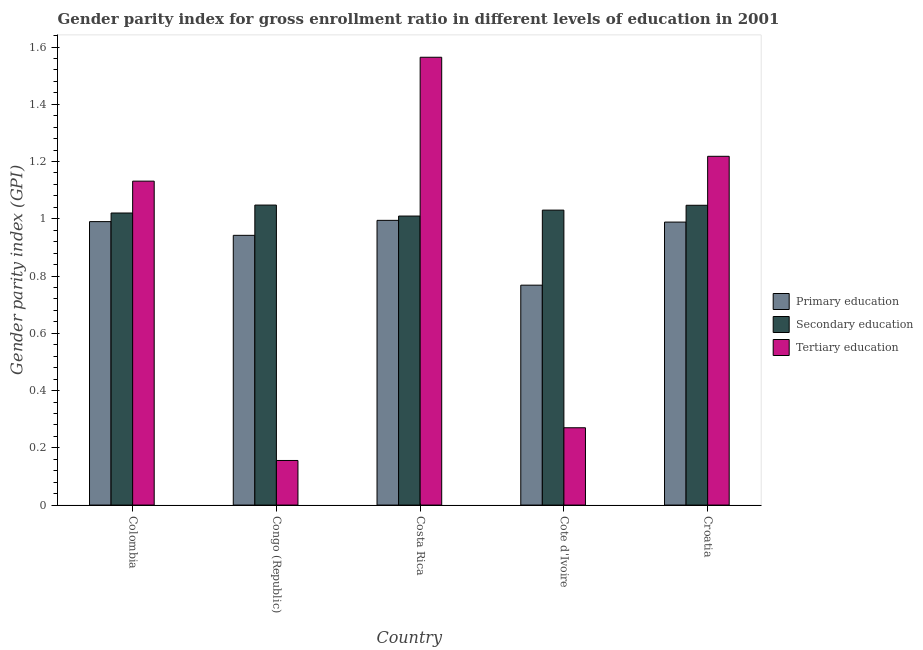How many different coloured bars are there?
Keep it short and to the point. 3. How many groups of bars are there?
Your answer should be very brief. 5. Are the number of bars on each tick of the X-axis equal?
Keep it short and to the point. Yes. How many bars are there on the 1st tick from the left?
Offer a terse response. 3. How many bars are there on the 4th tick from the right?
Offer a terse response. 3. What is the label of the 4th group of bars from the left?
Make the answer very short. Cote d'Ivoire. In how many cases, is the number of bars for a given country not equal to the number of legend labels?
Provide a short and direct response. 0. What is the gender parity index in secondary education in Costa Rica?
Your answer should be compact. 1.01. Across all countries, what is the maximum gender parity index in tertiary education?
Provide a short and direct response. 1.56. Across all countries, what is the minimum gender parity index in tertiary education?
Provide a short and direct response. 0.16. In which country was the gender parity index in primary education maximum?
Your answer should be compact. Costa Rica. In which country was the gender parity index in tertiary education minimum?
Provide a short and direct response. Congo (Republic). What is the total gender parity index in secondary education in the graph?
Give a very brief answer. 5.16. What is the difference between the gender parity index in primary education in Colombia and that in Croatia?
Provide a succinct answer. 0. What is the difference between the gender parity index in secondary education in Congo (Republic) and the gender parity index in tertiary education in Colombia?
Keep it short and to the point. -0.08. What is the average gender parity index in secondary education per country?
Your answer should be very brief. 1.03. What is the difference between the gender parity index in tertiary education and gender parity index in secondary education in Croatia?
Offer a terse response. 0.17. In how many countries, is the gender parity index in primary education greater than 0.8400000000000001 ?
Make the answer very short. 4. What is the ratio of the gender parity index in tertiary education in Costa Rica to that in Croatia?
Your answer should be compact. 1.28. What is the difference between the highest and the second highest gender parity index in tertiary education?
Make the answer very short. 0.35. What is the difference between the highest and the lowest gender parity index in tertiary education?
Make the answer very short. 1.41. In how many countries, is the gender parity index in primary education greater than the average gender parity index in primary education taken over all countries?
Your answer should be very brief. 4. What does the 3rd bar from the left in Croatia represents?
Keep it short and to the point. Tertiary education. What does the 2nd bar from the right in Cote d'Ivoire represents?
Your response must be concise. Secondary education. How many countries are there in the graph?
Give a very brief answer. 5. What is the difference between two consecutive major ticks on the Y-axis?
Offer a very short reply. 0.2. Does the graph contain any zero values?
Your response must be concise. No. Where does the legend appear in the graph?
Your answer should be compact. Center right. How many legend labels are there?
Your response must be concise. 3. How are the legend labels stacked?
Your answer should be very brief. Vertical. What is the title of the graph?
Ensure brevity in your answer.  Gender parity index for gross enrollment ratio in different levels of education in 2001. What is the label or title of the X-axis?
Your answer should be very brief. Country. What is the label or title of the Y-axis?
Offer a very short reply. Gender parity index (GPI). What is the Gender parity index (GPI) in Primary education in Colombia?
Give a very brief answer. 0.99. What is the Gender parity index (GPI) of Secondary education in Colombia?
Provide a succinct answer. 1.02. What is the Gender parity index (GPI) in Tertiary education in Colombia?
Offer a very short reply. 1.13. What is the Gender parity index (GPI) of Primary education in Congo (Republic)?
Make the answer very short. 0.94. What is the Gender parity index (GPI) of Secondary education in Congo (Republic)?
Keep it short and to the point. 1.05. What is the Gender parity index (GPI) in Tertiary education in Congo (Republic)?
Your response must be concise. 0.16. What is the Gender parity index (GPI) of Primary education in Costa Rica?
Offer a very short reply. 0.99. What is the Gender parity index (GPI) of Secondary education in Costa Rica?
Offer a very short reply. 1.01. What is the Gender parity index (GPI) in Tertiary education in Costa Rica?
Make the answer very short. 1.56. What is the Gender parity index (GPI) in Primary education in Cote d'Ivoire?
Your answer should be very brief. 0.77. What is the Gender parity index (GPI) of Secondary education in Cote d'Ivoire?
Your answer should be compact. 1.03. What is the Gender parity index (GPI) of Tertiary education in Cote d'Ivoire?
Your response must be concise. 0.27. What is the Gender parity index (GPI) of Primary education in Croatia?
Ensure brevity in your answer.  0.99. What is the Gender parity index (GPI) in Secondary education in Croatia?
Provide a succinct answer. 1.05. What is the Gender parity index (GPI) in Tertiary education in Croatia?
Provide a short and direct response. 1.22. Across all countries, what is the maximum Gender parity index (GPI) in Primary education?
Offer a terse response. 0.99. Across all countries, what is the maximum Gender parity index (GPI) of Secondary education?
Keep it short and to the point. 1.05. Across all countries, what is the maximum Gender parity index (GPI) of Tertiary education?
Keep it short and to the point. 1.56. Across all countries, what is the minimum Gender parity index (GPI) of Primary education?
Give a very brief answer. 0.77. Across all countries, what is the minimum Gender parity index (GPI) in Secondary education?
Provide a succinct answer. 1.01. Across all countries, what is the minimum Gender parity index (GPI) of Tertiary education?
Offer a very short reply. 0.16. What is the total Gender parity index (GPI) in Primary education in the graph?
Keep it short and to the point. 4.68. What is the total Gender parity index (GPI) of Secondary education in the graph?
Provide a succinct answer. 5.16. What is the total Gender parity index (GPI) in Tertiary education in the graph?
Ensure brevity in your answer.  4.34. What is the difference between the Gender parity index (GPI) in Primary education in Colombia and that in Congo (Republic)?
Ensure brevity in your answer.  0.05. What is the difference between the Gender parity index (GPI) in Secondary education in Colombia and that in Congo (Republic)?
Provide a succinct answer. -0.03. What is the difference between the Gender parity index (GPI) of Tertiary education in Colombia and that in Congo (Republic)?
Provide a succinct answer. 0.98. What is the difference between the Gender parity index (GPI) in Primary education in Colombia and that in Costa Rica?
Ensure brevity in your answer.  -0. What is the difference between the Gender parity index (GPI) in Secondary education in Colombia and that in Costa Rica?
Your response must be concise. 0.01. What is the difference between the Gender parity index (GPI) in Tertiary education in Colombia and that in Costa Rica?
Your answer should be very brief. -0.43. What is the difference between the Gender parity index (GPI) in Primary education in Colombia and that in Cote d'Ivoire?
Keep it short and to the point. 0.22. What is the difference between the Gender parity index (GPI) in Secondary education in Colombia and that in Cote d'Ivoire?
Your answer should be very brief. -0.01. What is the difference between the Gender parity index (GPI) of Tertiary education in Colombia and that in Cote d'Ivoire?
Offer a terse response. 0.86. What is the difference between the Gender parity index (GPI) in Primary education in Colombia and that in Croatia?
Your answer should be compact. 0. What is the difference between the Gender parity index (GPI) in Secondary education in Colombia and that in Croatia?
Keep it short and to the point. -0.03. What is the difference between the Gender parity index (GPI) of Tertiary education in Colombia and that in Croatia?
Keep it short and to the point. -0.09. What is the difference between the Gender parity index (GPI) in Primary education in Congo (Republic) and that in Costa Rica?
Offer a very short reply. -0.05. What is the difference between the Gender parity index (GPI) of Secondary education in Congo (Republic) and that in Costa Rica?
Provide a short and direct response. 0.04. What is the difference between the Gender parity index (GPI) in Tertiary education in Congo (Republic) and that in Costa Rica?
Your response must be concise. -1.41. What is the difference between the Gender parity index (GPI) of Primary education in Congo (Republic) and that in Cote d'Ivoire?
Keep it short and to the point. 0.17. What is the difference between the Gender parity index (GPI) of Secondary education in Congo (Republic) and that in Cote d'Ivoire?
Ensure brevity in your answer.  0.02. What is the difference between the Gender parity index (GPI) of Tertiary education in Congo (Republic) and that in Cote d'Ivoire?
Give a very brief answer. -0.11. What is the difference between the Gender parity index (GPI) of Primary education in Congo (Republic) and that in Croatia?
Keep it short and to the point. -0.05. What is the difference between the Gender parity index (GPI) of Secondary education in Congo (Republic) and that in Croatia?
Offer a very short reply. 0. What is the difference between the Gender parity index (GPI) of Tertiary education in Congo (Republic) and that in Croatia?
Provide a succinct answer. -1.06. What is the difference between the Gender parity index (GPI) of Primary education in Costa Rica and that in Cote d'Ivoire?
Your answer should be compact. 0.23. What is the difference between the Gender parity index (GPI) in Secondary education in Costa Rica and that in Cote d'Ivoire?
Provide a short and direct response. -0.02. What is the difference between the Gender parity index (GPI) in Tertiary education in Costa Rica and that in Cote d'Ivoire?
Provide a short and direct response. 1.29. What is the difference between the Gender parity index (GPI) of Primary education in Costa Rica and that in Croatia?
Your response must be concise. 0.01. What is the difference between the Gender parity index (GPI) of Secondary education in Costa Rica and that in Croatia?
Offer a very short reply. -0.04. What is the difference between the Gender parity index (GPI) of Tertiary education in Costa Rica and that in Croatia?
Provide a short and direct response. 0.35. What is the difference between the Gender parity index (GPI) in Primary education in Cote d'Ivoire and that in Croatia?
Ensure brevity in your answer.  -0.22. What is the difference between the Gender parity index (GPI) in Secondary education in Cote d'Ivoire and that in Croatia?
Offer a very short reply. -0.02. What is the difference between the Gender parity index (GPI) of Tertiary education in Cote d'Ivoire and that in Croatia?
Give a very brief answer. -0.95. What is the difference between the Gender parity index (GPI) in Primary education in Colombia and the Gender parity index (GPI) in Secondary education in Congo (Republic)?
Your answer should be very brief. -0.06. What is the difference between the Gender parity index (GPI) in Primary education in Colombia and the Gender parity index (GPI) in Tertiary education in Congo (Republic)?
Keep it short and to the point. 0.83. What is the difference between the Gender parity index (GPI) in Secondary education in Colombia and the Gender parity index (GPI) in Tertiary education in Congo (Republic)?
Offer a very short reply. 0.86. What is the difference between the Gender parity index (GPI) of Primary education in Colombia and the Gender parity index (GPI) of Secondary education in Costa Rica?
Your response must be concise. -0.02. What is the difference between the Gender parity index (GPI) in Primary education in Colombia and the Gender parity index (GPI) in Tertiary education in Costa Rica?
Make the answer very short. -0.57. What is the difference between the Gender parity index (GPI) in Secondary education in Colombia and the Gender parity index (GPI) in Tertiary education in Costa Rica?
Your response must be concise. -0.54. What is the difference between the Gender parity index (GPI) of Primary education in Colombia and the Gender parity index (GPI) of Secondary education in Cote d'Ivoire?
Your answer should be very brief. -0.04. What is the difference between the Gender parity index (GPI) in Primary education in Colombia and the Gender parity index (GPI) in Tertiary education in Cote d'Ivoire?
Ensure brevity in your answer.  0.72. What is the difference between the Gender parity index (GPI) in Secondary education in Colombia and the Gender parity index (GPI) in Tertiary education in Cote d'Ivoire?
Provide a short and direct response. 0.75. What is the difference between the Gender parity index (GPI) in Primary education in Colombia and the Gender parity index (GPI) in Secondary education in Croatia?
Keep it short and to the point. -0.06. What is the difference between the Gender parity index (GPI) of Primary education in Colombia and the Gender parity index (GPI) of Tertiary education in Croatia?
Provide a short and direct response. -0.23. What is the difference between the Gender parity index (GPI) of Secondary education in Colombia and the Gender parity index (GPI) of Tertiary education in Croatia?
Provide a succinct answer. -0.2. What is the difference between the Gender parity index (GPI) of Primary education in Congo (Republic) and the Gender parity index (GPI) of Secondary education in Costa Rica?
Your response must be concise. -0.07. What is the difference between the Gender parity index (GPI) in Primary education in Congo (Republic) and the Gender parity index (GPI) in Tertiary education in Costa Rica?
Your response must be concise. -0.62. What is the difference between the Gender parity index (GPI) of Secondary education in Congo (Republic) and the Gender parity index (GPI) of Tertiary education in Costa Rica?
Keep it short and to the point. -0.52. What is the difference between the Gender parity index (GPI) of Primary education in Congo (Republic) and the Gender parity index (GPI) of Secondary education in Cote d'Ivoire?
Offer a very short reply. -0.09. What is the difference between the Gender parity index (GPI) of Primary education in Congo (Republic) and the Gender parity index (GPI) of Tertiary education in Cote d'Ivoire?
Offer a terse response. 0.67. What is the difference between the Gender parity index (GPI) of Secondary education in Congo (Republic) and the Gender parity index (GPI) of Tertiary education in Cote d'Ivoire?
Keep it short and to the point. 0.78. What is the difference between the Gender parity index (GPI) in Primary education in Congo (Republic) and the Gender parity index (GPI) in Secondary education in Croatia?
Keep it short and to the point. -0.11. What is the difference between the Gender parity index (GPI) in Primary education in Congo (Republic) and the Gender parity index (GPI) in Tertiary education in Croatia?
Your answer should be compact. -0.28. What is the difference between the Gender parity index (GPI) of Secondary education in Congo (Republic) and the Gender parity index (GPI) of Tertiary education in Croatia?
Ensure brevity in your answer.  -0.17. What is the difference between the Gender parity index (GPI) of Primary education in Costa Rica and the Gender parity index (GPI) of Secondary education in Cote d'Ivoire?
Your answer should be very brief. -0.04. What is the difference between the Gender parity index (GPI) in Primary education in Costa Rica and the Gender parity index (GPI) in Tertiary education in Cote d'Ivoire?
Make the answer very short. 0.72. What is the difference between the Gender parity index (GPI) in Secondary education in Costa Rica and the Gender parity index (GPI) in Tertiary education in Cote d'Ivoire?
Your answer should be very brief. 0.74. What is the difference between the Gender parity index (GPI) of Primary education in Costa Rica and the Gender parity index (GPI) of Secondary education in Croatia?
Ensure brevity in your answer.  -0.05. What is the difference between the Gender parity index (GPI) of Primary education in Costa Rica and the Gender parity index (GPI) of Tertiary education in Croatia?
Your answer should be very brief. -0.22. What is the difference between the Gender parity index (GPI) of Secondary education in Costa Rica and the Gender parity index (GPI) of Tertiary education in Croatia?
Ensure brevity in your answer.  -0.21. What is the difference between the Gender parity index (GPI) in Primary education in Cote d'Ivoire and the Gender parity index (GPI) in Secondary education in Croatia?
Offer a terse response. -0.28. What is the difference between the Gender parity index (GPI) in Primary education in Cote d'Ivoire and the Gender parity index (GPI) in Tertiary education in Croatia?
Give a very brief answer. -0.45. What is the difference between the Gender parity index (GPI) in Secondary education in Cote d'Ivoire and the Gender parity index (GPI) in Tertiary education in Croatia?
Your answer should be very brief. -0.19. What is the average Gender parity index (GPI) in Primary education per country?
Keep it short and to the point. 0.94. What is the average Gender parity index (GPI) in Secondary education per country?
Offer a very short reply. 1.03. What is the average Gender parity index (GPI) in Tertiary education per country?
Your answer should be compact. 0.87. What is the difference between the Gender parity index (GPI) in Primary education and Gender parity index (GPI) in Secondary education in Colombia?
Provide a succinct answer. -0.03. What is the difference between the Gender parity index (GPI) of Primary education and Gender parity index (GPI) of Tertiary education in Colombia?
Provide a short and direct response. -0.14. What is the difference between the Gender parity index (GPI) in Secondary education and Gender parity index (GPI) in Tertiary education in Colombia?
Make the answer very short. -0.11. What is the difference between the Gender parity index (GPI) of Primary education and Gender parity index (GPI) of Secondary education in Congo (Republic)?
Make the answer very short. -0.11. What is the difference between the Gender parity index (GPI) of Primary education and Gender parity index (GPI) of Tertiary education in Congo (Republic)?
Offer a very short reply. 0.79. What is the difference between the Gender parity index (GPI) of Secondary education and Gender parity index (GPI) of Tertiary education in Congo (Republic)?
Your response must be concise. 0.89. What is the difference between the Gender parity index (GPI) of Primary education and Gender parity index (GPI) of Secondary education in Costa Rica?
Ensure brevity in your answer.  -0.01. What is the difference between the Gender parity index (GPI) of Primary education and Gender parity index (GPI) of Tertiary education in Costa Rica?
Provide a succinct answer. -0.57. What is the difference between the Gender parity index (GPI) in Secondary education and Gender parity index (GPI) in Tertiary education in Costa Rica?
Ensure brevity in your answer.  -0.55. What is the difference between the Gender parity index (GPI) of Primary education and Gender parity index (GPI) of Secondary education in Cote d'Ivoire?
Your response must be concise. -0.26. What is the difference between the Gender parity index (GPI) in Primary education and Gender parity index (GPI) in Tertiary education in Cote d'Ivoire?
Offer a terse response. 0.5. What is the difference between the Gender parity index (GPI) of Secondary education and Gender parity index (GPI) of Tertiary education in Cote d'Ivoire?
Your response must be concise. 0.76. What is the difference between the Gender parity index (GPI) of Primary education and Gender parity index (GPI) of Secondary education in Croatia?
Offer a terse response. -0.06. What is the difference between the Gender parity index (GPI) of Primary education and Gender parity index (GPI) of Tertiary education in Croatia?
Offer a very short reply. -0.23. What is the difference between the Gender parity index (GPI) of Secondary education and Gender parity index (GPI) of Tertiary education in Croatia?
Provide a short and direct response. -0.17. What is the ratio of the Gender parity index (GPI) in Primary education in Colombia to that in Congo (Republic)?
Offer a very short reply. 1.05. What is the ratio of the Gender parity index (GPI) of Secondary education in Colombia to that in Congo (Republic)?
Your answer should be compact. 0.97. What is the ratio of the Gender parity index (GPI) of Tertiary education in Colombia to that in Congo (Republic)?
Offer a terse response. 7.26. What is the ratio of the Gender parity index (GPI) in Secondary education in Colombia to that in Costa Rica?
Offer a terse response. 1.01. What is the ratio of the Gender parity index (GPI) of Tertiary education in Colombia to that in Costa Rica?
Give a very brief answer. 0.72. What is the ratio of the Gender parity index (GPI) of Primary education in Colombia to that in Cote d'Ivoire?
Provide a succinct answer. 1.29. What is the ratio of the Gender parity index (GPI) of Secondary education in Colombia to that in Cote d'Ivoire?
Your answer should be compact. 0.99. What is the ratio of the Gender parity index (GPI) of Tertiary education in Colombia to that in Cote d'Ivoire?
Your response must be concise. 4.19. What is the ratio of the Gender parity index (GPI) of Primary education in Colombia to that in Croatia?
Your answer should be very brief. 1. What is the ratio of the Gender parity index (GPI) in Secondary education in Colombia to that in Croatia?
Offer a terse response. 0.97. What is the ratio of the Gender parity index (GPI) of Tertiary education in Colombia to that in Croatia?
Offer a terse response. 0.93. What is the ratio of the Gender parity index (GPI) in Primary education in Congo (Republic) to that in Costa Rica?
Keep it short and to the point. 0.95. What is the ratio of the Gender parity index (GPI) in Secondary education in Congo (Republic) to that in Costa Rica?
Your response must be concise. 1.04. What is the ratio of the Gender parity index (GPI) of Tertiary education in Congo (Republic) to that in Costa Rica?
Your answer should be very brief. 0.1. What is the ratio of the Gender parity index (GPI) in Primary education in Congo (Republic) to that in Cote d'Ivoire?
Your response must be concise. 1.23. What is the ratio of the Gender parity index (GPI) of Secondary education in Congo (Republic) to that in Cote d'Ivoire?
Provide a succinct answer. 1.02. What is the ratio of the Gender parity index (GPI) of Tertiary education in Congo (Republic) to that in Cote d'Ivoire?
Offer a very short reply. 0.58. What is the ratio of the Gender parity index (GPI) in Primary education in Congo (Republic) to that in Croatia?
Provide a succinct answer. 0.95. What is the ratio of the Gender parity index (GPI) of Secondary education in Congo (Republic) to that in Croatia?
Your answer should be very brief. 1. What is the ratio of the Gender parity index (GPI) in Tertiary education in Congo (Republic) to that in Croatia?
Offer a terse response. 0.13. What is the ratio of the Gender parity index (GPI) of Primary education in Costa Rica to that in Cote d'Ivoire?
Make the answer very short. 1.29. What is the ratio of the Gender parity index (GPI) of Secondary education in Costa Rica to that in Cote d'Ivoire?
Provide a short and direct response. 0.98. What is the ratio of the Gender parity index (GPI) of Tertiary education in Costa Rica to that in Cote d'Ivoire?
Ensure brevity in your answer.  5.79. What is the ratio of the Gender parity index (GPI) of Tertiary education in Costa Rica to that in Croatia?
Give a very brief answer. 1.28. What is the ratio of the Gender parity index (GPI) in Primary education in Cote d'Ivoire to that in Croatia?
Ensure brevity in your answer.  0.78. What is the ratio of the Gender parity index (GPI) in Secondary education in Cote d'Ivoire to that in Croatia?
Offer a very short reply. 0.98. What is the ratio of the Gender parity index (GPI) of Tertiary education in Cote d'Ivoire to that in Croatia?
Ensure brevity in your answer.  0.22. What is the difference between the highest and the second highest Gender parity index (GPI) of Primary education?
Your answer should be very brief. 0. What is the difference between the highest and the second highest Gender parity index (GPI) of Secondary education?
Make the answer very short. 0. What is the difference between the highest and the second highest Gender parity index (GPI) of Tertiary education?
Offer a terse response. 0.35. What is the difference between the highest and the lowest Gender parity index (GPI) of Primary education?
Your answer should be compact. 0.23. What is the difference between the highest and the lowest Gender parity index (GPI) in Secondary education?
Offer a very short reply. 0.04. What is the difference between the highest and the lowest Gender parity index (GPI) of Tertiary education?
Your answer should be compact. 1.41. 